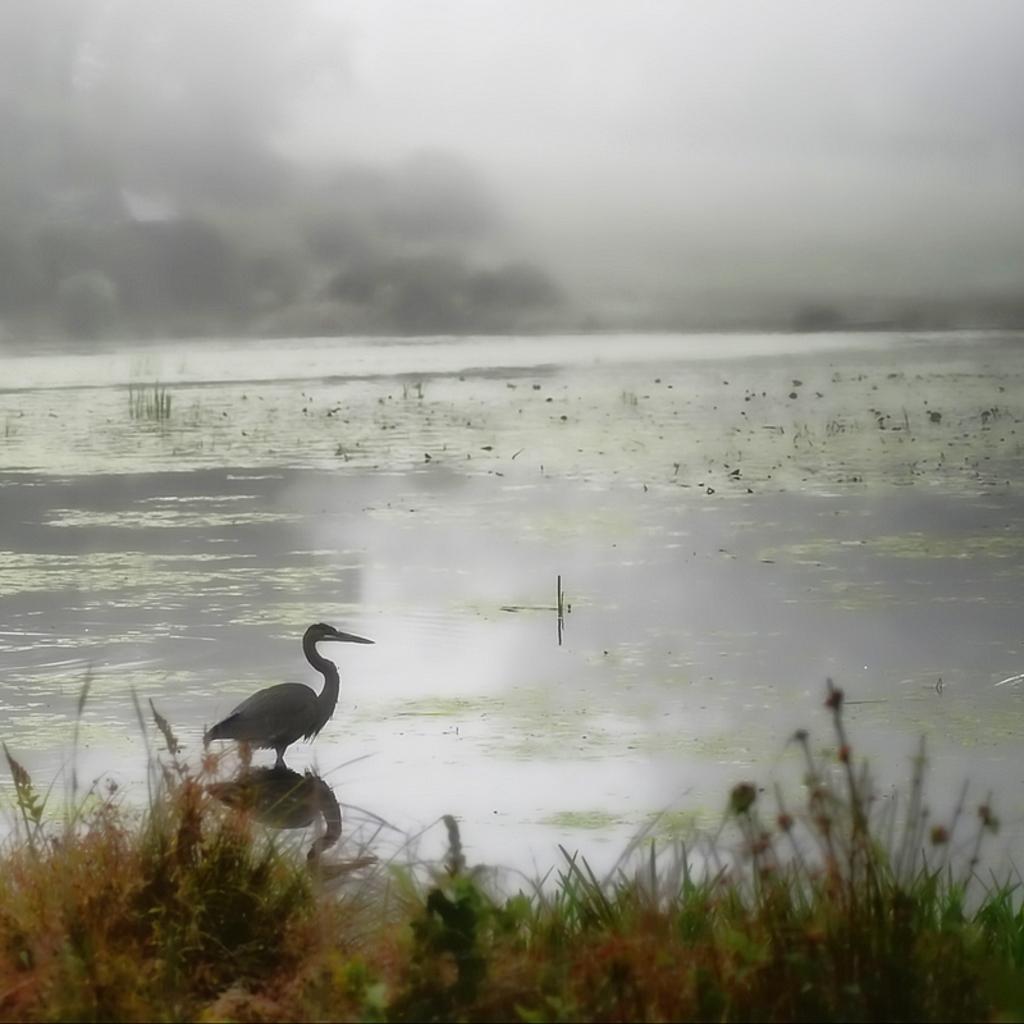How would you summarize this image in a sentence or two? In this image I can see the bird in the water. To the side of the bird I can see the grass. In the background I can see the clouds and the sky. 